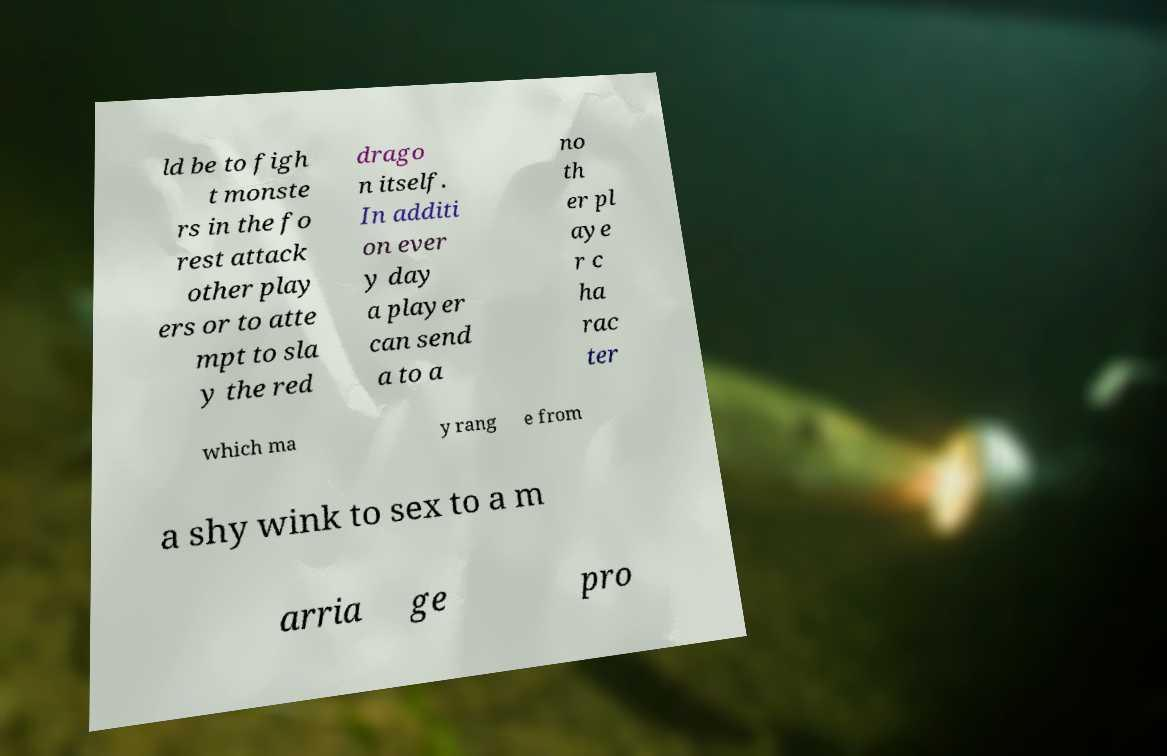Could you extract and type out the text from this image? ld be to figh t monste rs in the fo rest attack other play ers or to atte mpt to sla y the red drago n itself. In additi on ever y day a player can send a to a no th er pl aye r c ha rac ter which ma y rang e from a shy wink to sex to a m arria ge pro 